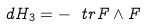<formula> <loc_0><loc_0><loc_500><loc_500>d H _ { 3 } = - \ t r F \wedge F</formula> 